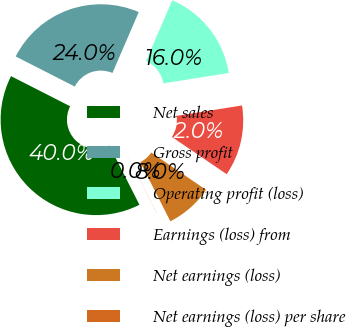Convert chart. <chart><loc_0><loc_0><loc_500><loc_500><pie_chart><fcel>Net sales<fcel>Gross profit<fcel>Operating profit (loss)<fcel>Earnings (loss) from<fcel>Net earnings (loss)<fcel>Net earnings (loss) per share<nl><fcel>39.97%<fcel>23.99%<fcel>16.0%<fcel>12.01%<fcel>8.01%<fcel>0.02%<nl></chart> 